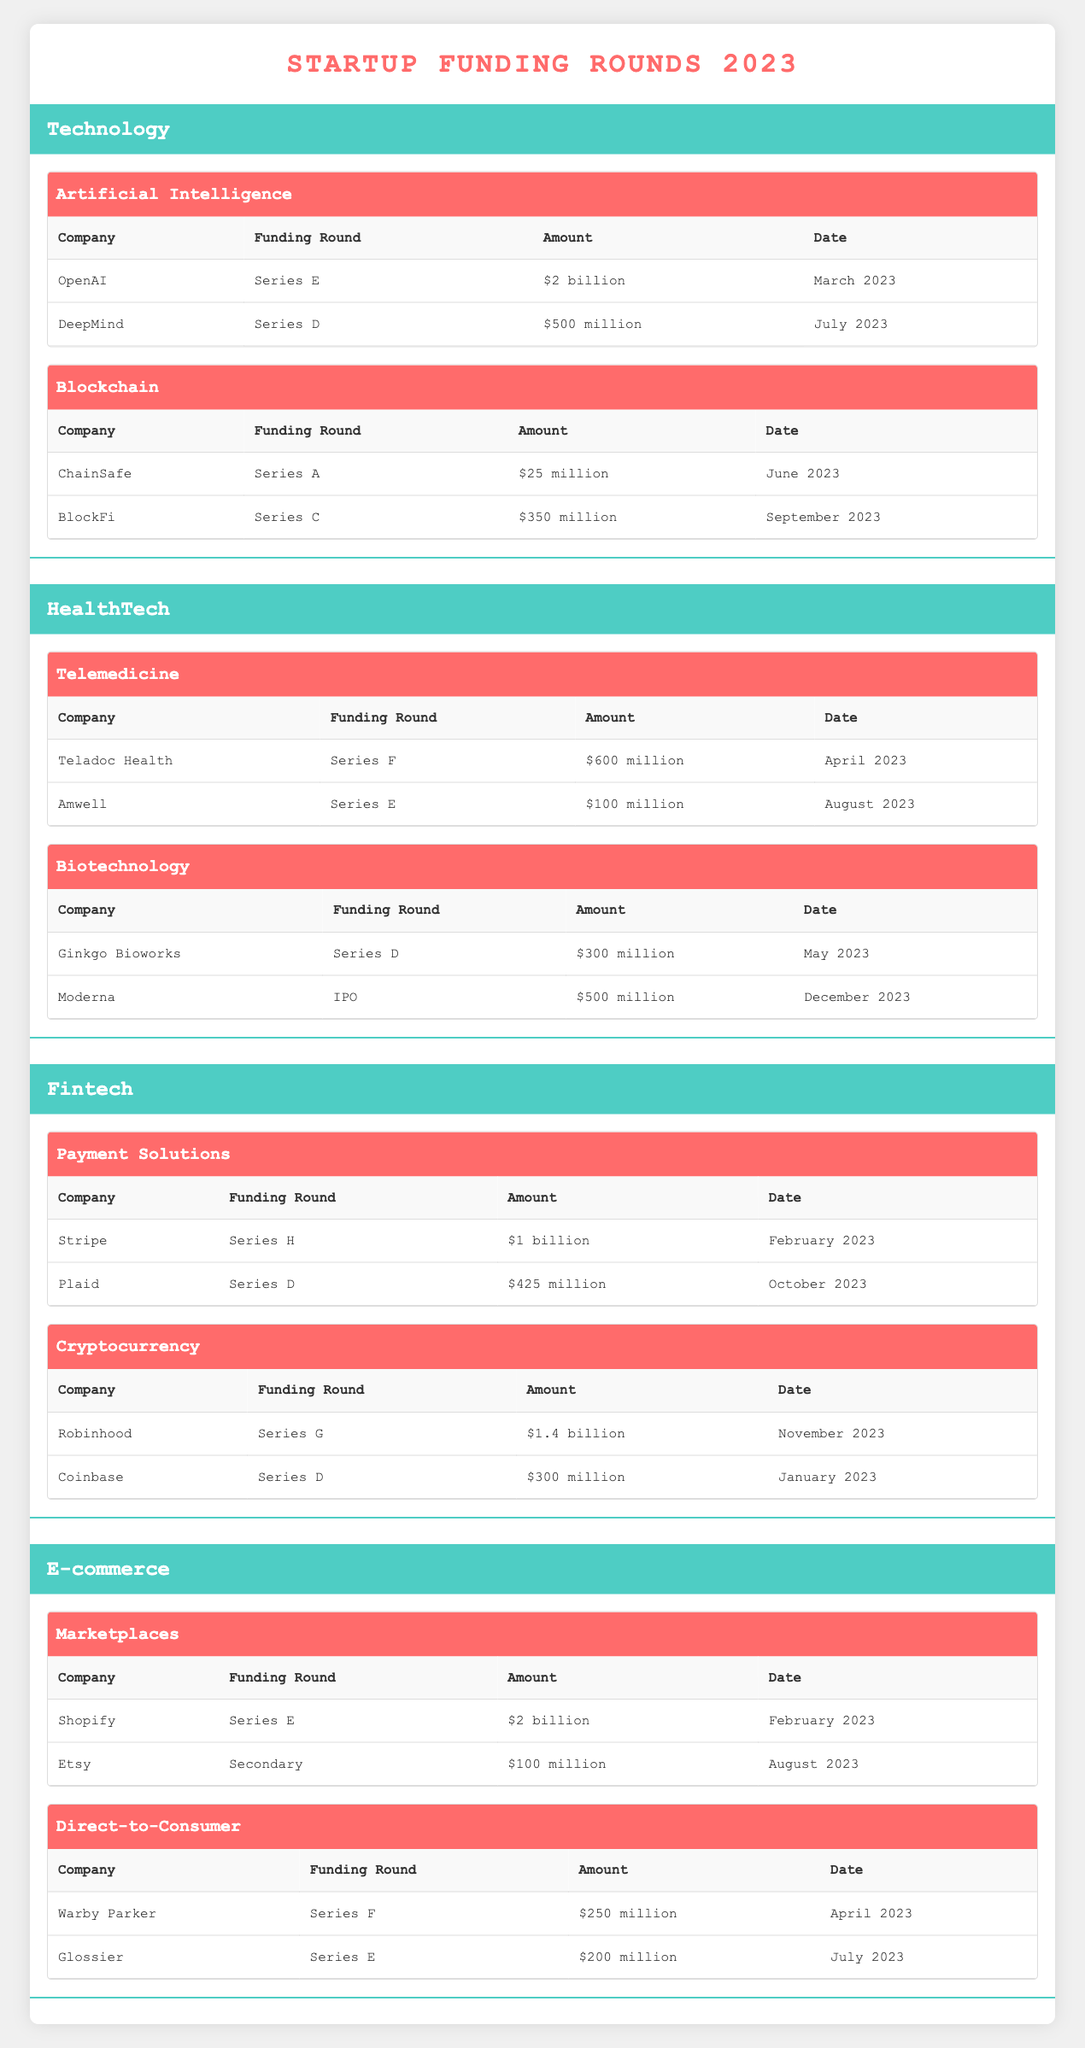What is the total amount raised by startups in the Telemedicine sector? There are two startups in the Telemedicine sector: Teladoc Health with $600 million and Amwell with $100 million. Adding these together: $600 million + $100 million = $700 million.
Answer: $700 million Which company received the highest funding amount in the E-commerce sector? In the E-commerce sector, Shopify raised $2 billion in Series E funding, which is the highest amount compared to Etsy's $100 million in Secondary funding.
Answer: Shopify Did Coinbase raise more funds than BlockFi in their respective rounds? Coinbase raised $300 million in its Series D round, while BlockFi raised $350 million in its Series C round. Since $300 million is less than $350 million, the statement is false.
Answer: No How many companies in the HealthTech sector raised less than $400 million? In the HealthTech sector, Amwell raised $100 million, and Ginkgo Bioworks raised $300 million. The other two companies, Teladoc Health and Moderna, raised $600 million and $500 million, respectively. Therefore, two companies raised less than $400 million.
Answer: 2 What is the average funding amount raised in the Artificial Intelligence sector? OpenAI raised $2 billion and DeepMind raised $500 million. First, convert these amounts to numbers: 2 billion = 2000 million, so the total is 2000 million + 500 million = 2500 million. Then, divide by the number of companies, which is 2: 2500 million / 2 = 1250 million.
Answer: $1.25 billion Which sector had the least amount raised by its highest-funded company? In Blockchain, ChainSafe raised $25 million, which is the least among the highest-funded companies across all industries compared to the highest amounts in other sectors. The highest amounts are $2 billion in Technology and E-commerce, $600 million in HealthTech, and significant funding in Fintech.
Answer: Blockchain Did any companies raise funds in July 2023? Yes, DeepMind received $500 million in Series D funding, and Glossier raised $200 million in Series E funding in July 2023. Therefore, the answer is true.
Answer: Yes What is the total funding amount across all startups in the Fintech sector? In the Payment Solutions, Stripe raised $1 billion and Plaid raised $425 million. In Cryptocurrency, Robinhood raised $1.4 billion and Coinbase raised $300 million. Adding these amounts gives: $1 billion + $425 million + $1.4 billion + $300 million = $3.125 billion.
Answer: $3.125 billion What is the funding round type for the lowest funded startup in the table? The lowest funded startup is ChainSafe in the Blockchain sector, which raised $25 million in a Series A funding round. Thus, the funding round type is Series A.
Answer: Series A 